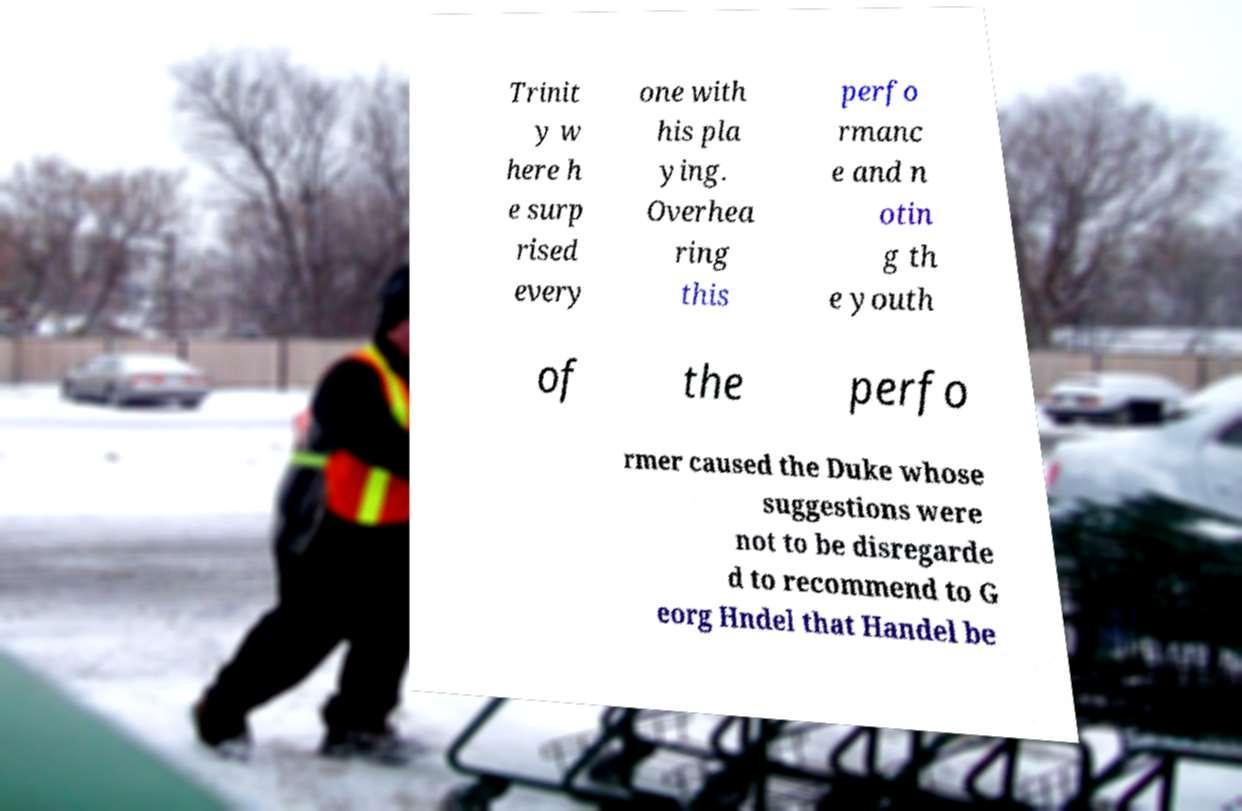Please read and relay the text visible in this image. What does it say? Trinit y w here h e surp rised every one with his pla ying. Overhea ring this perfo rmanc e and n otin g th e youth of the perfo rmer caused the Duke whose suggestions were not to be disregarde d to recommend to G eorg Hndel that Handel be 